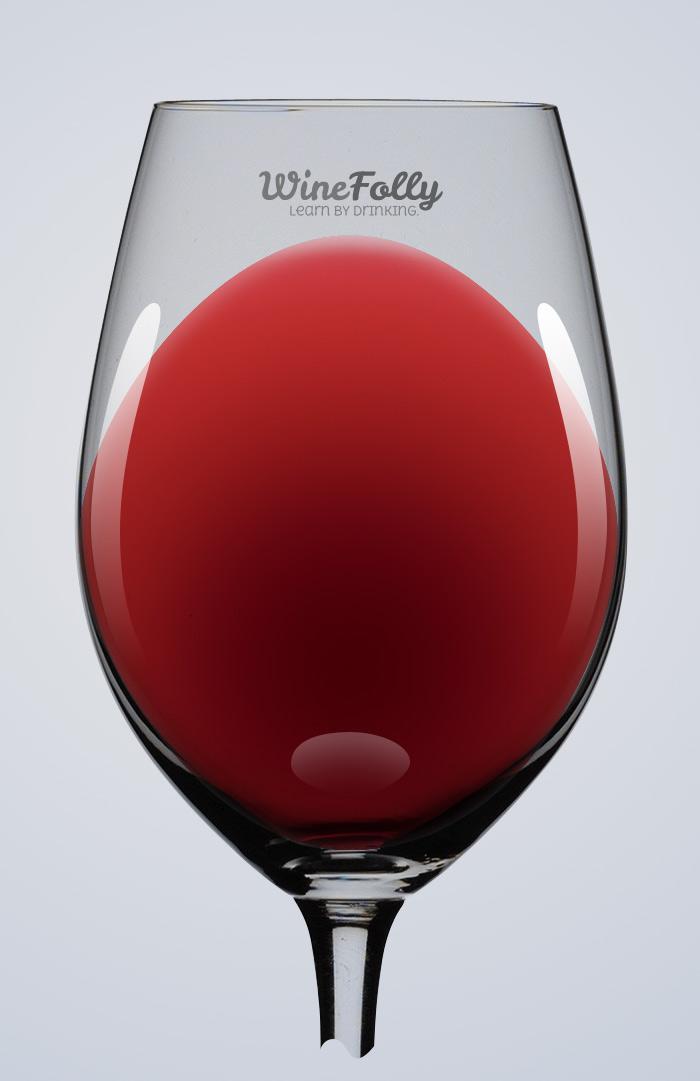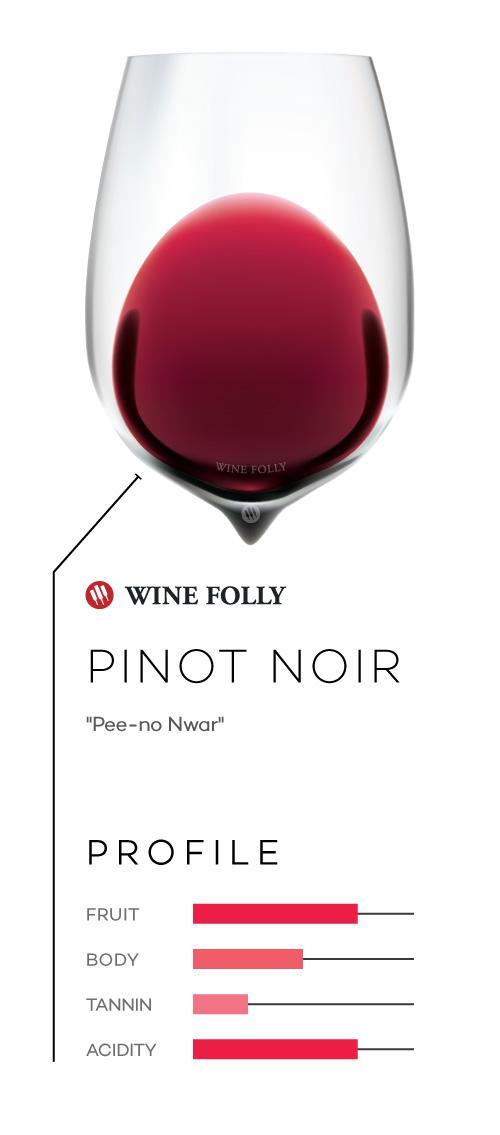The first image is the image on the left, the second image is the image on the right. For the images shown, is this caption "The wineglass in the image on the right appears to have a point at its base." true? Answer yes or no. Yes. The first image is the image on the left, the second image is the image on the right. Given the left and right images, does the statement "An image shows wine glass with wine inside level and flat on top." hold true? Answer yes or no. No. 